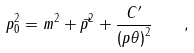<formula> <loc_0><loc_0><loc_500><loc_500>p _ { 0 } ^ { 2 } = m ^ { 2 } + \vec { p } ^ { 2 } + \frac { C ^ { \prime } } { \left ( p \theta \right ) ^ { 2 } } \quad ,</formula> 